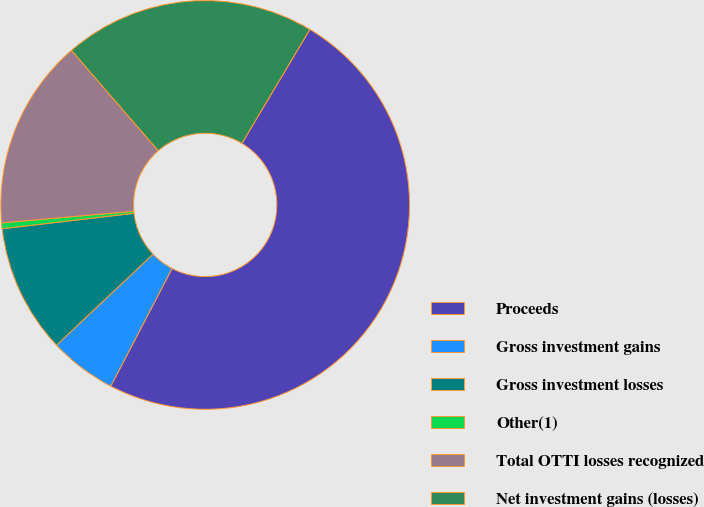Convert chart to OTSL. <chart><loc_0><loc_0><loc_500><loc_500><pie_chart><fcel>Proceeds<fcel>Gross investment gains<fcel>Gross investment losses<fcel>Other(1)<fcel>Total OTTI losses recognized<fcel>Net investment gains (losses)<nl><fcel>49.09%<fcel>5.32%<fcel>10.18%<fcel>0.46%<fcel>15.05%<fcel>19.91%<nl></chart> 